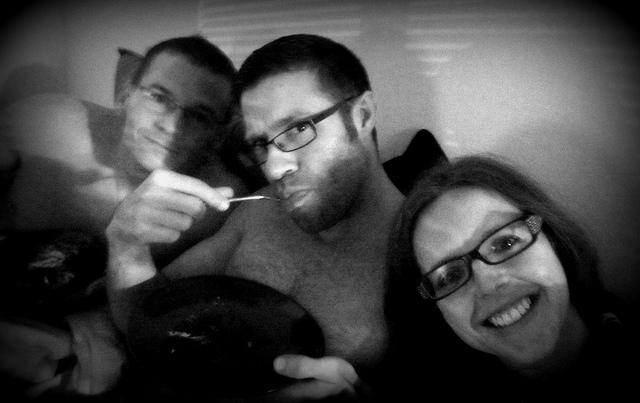What is a good word to describe all of these people? Please explain your reasoning. bespectacled. We could call them bespectacled because they are all wearing glasses. 